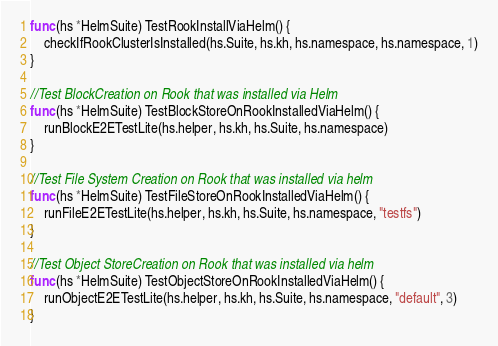<code> <loc_0><loc_0><loc_500><loc_500><_Go_>func (hs *HelmSuite) TestRookInstallViaHelm() {
	checkIfRookClusterIsInstalled(hs.Suite, hs.kh, hs.namespace, hs.namespace, 1)
}

//Test BlockCreation on Rook that was installed via Helm
func (hs *HelmSuite) TestBlockStoreOnRookInstalledViaHelm() {
	runBlockE2ETestLite(hs.helper, hs.kh, hs.Suite, hs.namespace)
}

//Test File System Creation on Rook that was installed via helm
func (hs *HelmSuite) TestFileStoreOnRookInstalledViaHelm() {
	runFileE2ETestLite(hs.helper, hs.kh, hs.Suite, hs.namespace, "testfs")
}

//Test Object StoreCreation on Rook that was installed via helm
func (hs *HelmSuite) TestObjectStoreOnRookInstalledViaHelm() {
	runObjectE2ETestLite(hs.helper, hs.kh, hs.Suite, hs.namespace, "default", 3)
}
</code> 